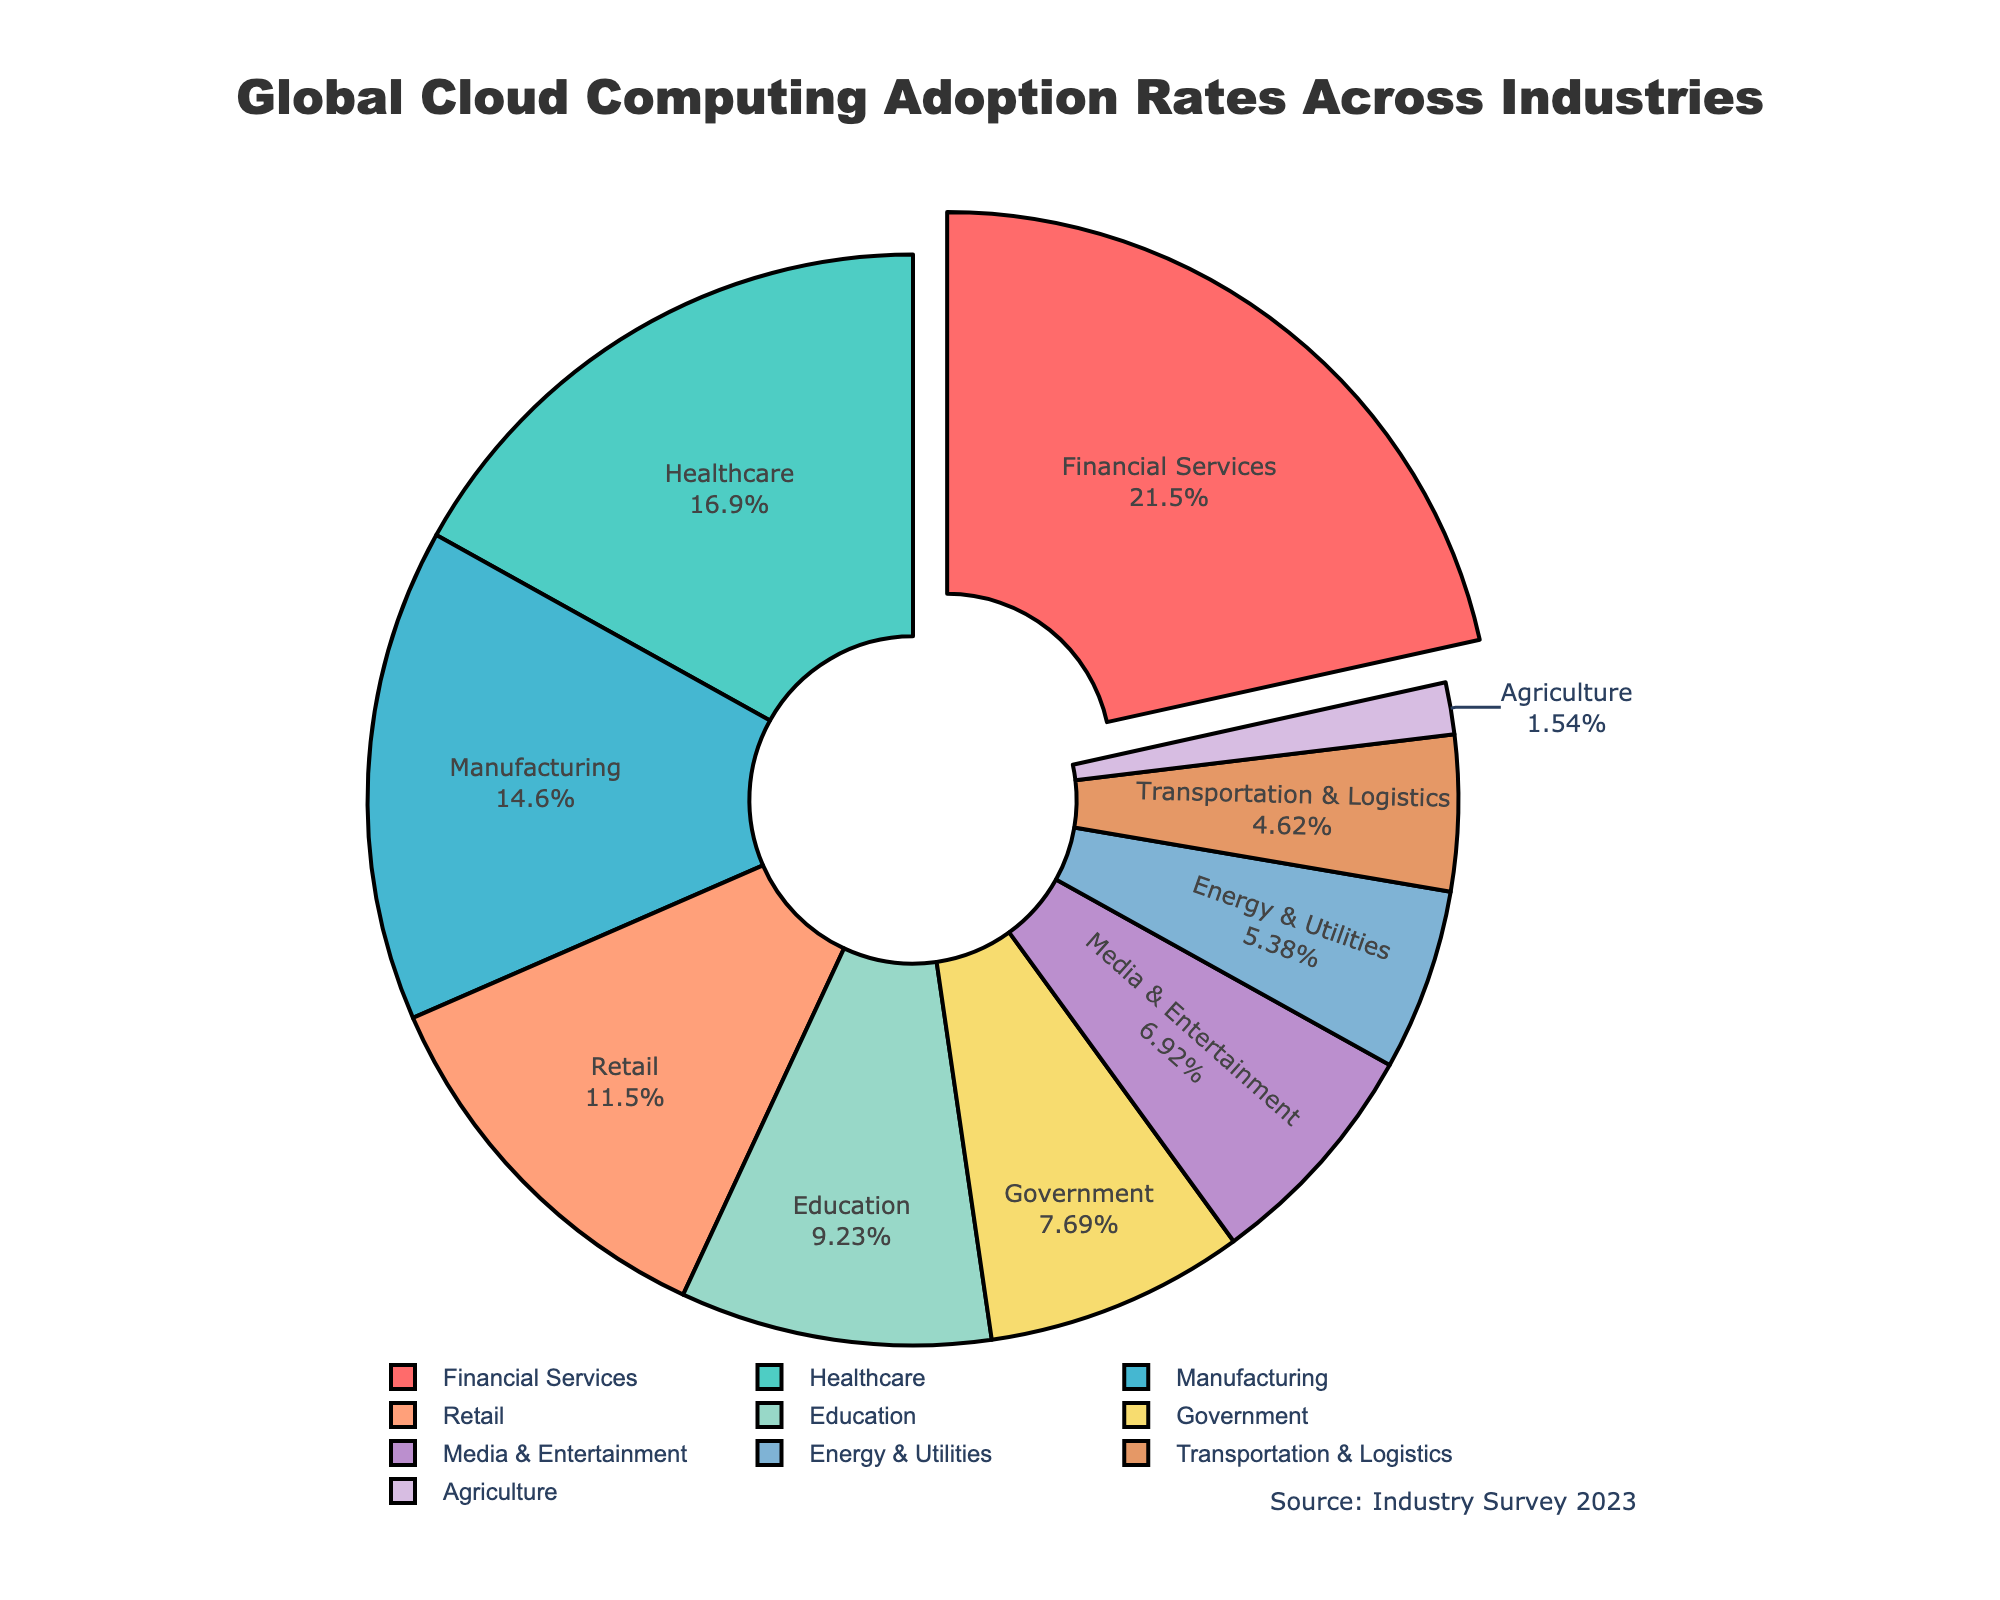What is the industry with the highest adoption rate of cloud computing? The largest sector in the pie chart, which is highlighted by being slightly pulled out, is Financial Services. This indicates that Financial Services has the highest adoption rate of cloud computing.
Answer: Financial Services Which industry has the lowest adoption rate of cloud computing? By looking at the smallest section in the pie chart, we can see that Agriculture has the smallest share.
Answer: Agriculture What is the combined adoption rate for the Manufacturing and Retail sectors? According to the pie chart, Manufacturing has an adoption rate of 19% and Retail has an adoption rate of 15%. Adding these together, the combined rate is 19% + 15% = 34%.
Answer: 34% Which industry has a higher adoption rate: Government or Education? By comparing the chart segments for Government and Education, we can see that Education has a larger share (12%) compared to Government (10%).
Answer: Education What percentage of the total adoption rate do Healthcare and Financial Services represent together? The adoption rates for Healthcare and Financial Services are 22% and 28%, respectively. Adding them gives 22% + 28% = 50%.
Answer: 50% How does the adoption rate of the Healthcare sector compare to the Manufacturing sector? The pie chart shows Healthcare with an adoption rate of 22% and Manufacturing with 19%. Comparing these, Healthcare has a 3% higher adoption rate than Manufacturing.
Answer: Healthcare is 3% higher Which color is used for the Financial Services industry on the pie chart? Financial Services, being the largest segment and slightly pulled out, is colored in red.
Answer: Red What is the difference in adoption rates between the Education and Transportation & Logistics sectors? The adoption rate for Education is 12% and for Transportation & Logistics, it is 6%. The difference is 12% - 6% = 6%.
Answer: 6% What is the combined adoption rate for all sectors with more than 20% adoption rate? Only Financial Services (28%) and Healthcare (22%) have adoption rates more than 20%. Combined, their adoption rate is 28% + 22% = 50%.
Answer: 50% What is the median adoption rate of all industries? To find the median, list all adoption rates in ascending order: 2%, 6%, 7%, 9%, 10%, 12%, 15%, 19%, 22%, 28%. The middle values are 12% and 15%, and the average of these two is (12% + 15%) / 2 = 13.5%.
Answer: 13.5% 